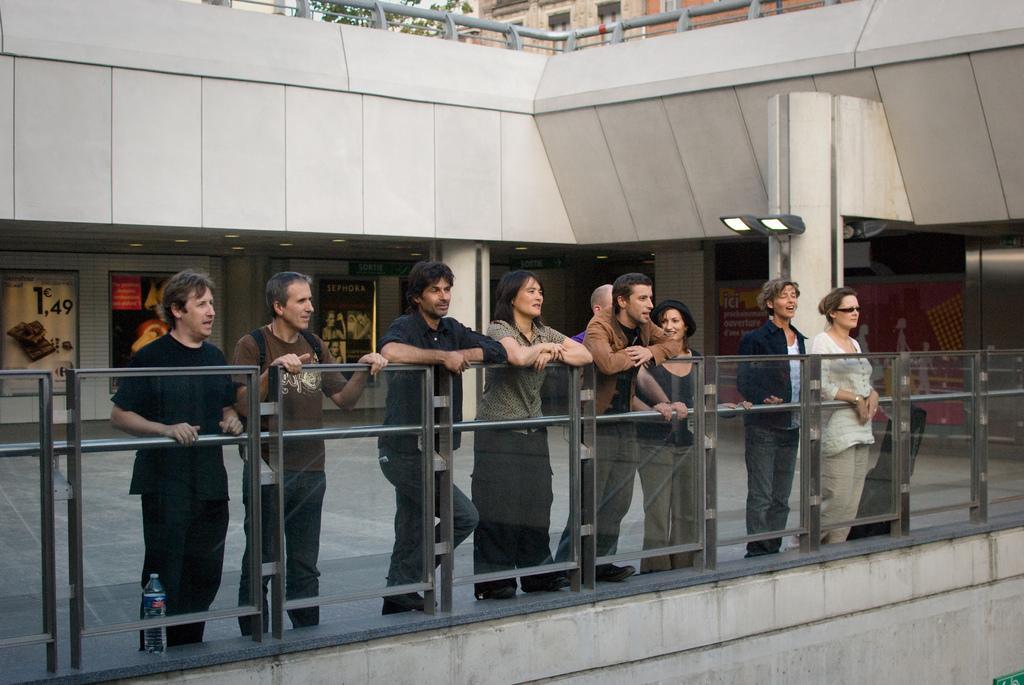In one or two sentences, can you explain what this image depicts? In this image I can see the group of people with different color dresses. These people are standing in-front of the glass fence. In the background I can see many boards to the wall. I can see the plant in the top. 